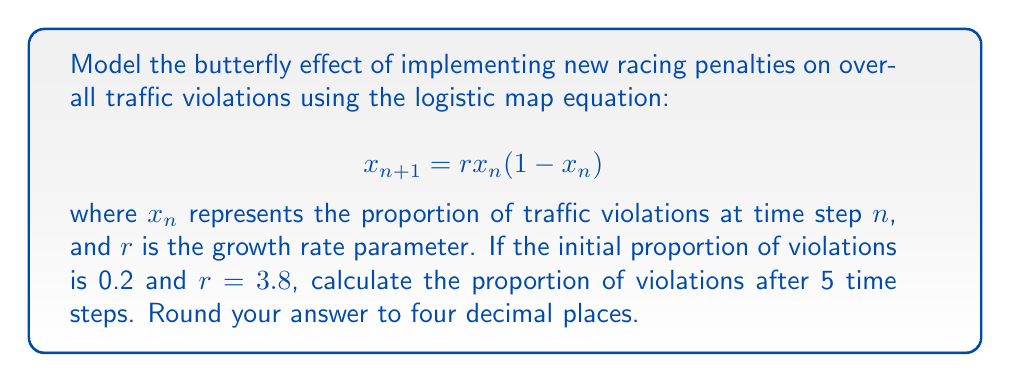Give your solution to this math problem. 1. We start with the logistic map equation: $x_{n+1} = rx_n(1-x_n)$
2. Given: $x_0 = 0.2$ (initial proportion) and $r = 3.8$ (growth rate)
3. Calculate for 5 time steps:

   Step 1: $x_1 = 3.8 * 0.2 * (1-0.2) = 0.608$
   Step 2: $x_2 = 3.8 * 0.608 * (1-0.608) = 0.9085696$
   Step 3: $x_3 = 3.8 * 0.9085696 * (1-0.9085696) = 0.3162509$
   Step 4: $x_4 = 3.8 * 0.3162509 * (1-0.3162509) = 0.8207377$
   Step 5: $x_5 = 3.8 * 0.8207377 * (1-0.8207377) = 0.5645756$

4. Round the final result to four decimal places: 0.5646
Answer: 0.5646 